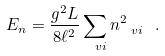Convert formula to latex. <formula><loc_0><loc_0><loc_500><loc_500>E _ { n } = \frac { g ^ { 2 } L } { 8 \ell ^ { 2 } } \sum _ { \ v i } n _ { \ v i } ^ { 2 } \ .</formula> 